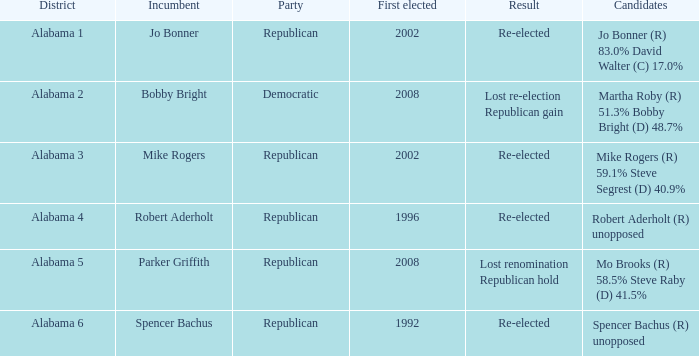Name the incumbent for alabama 6 Spencer Bachus. 